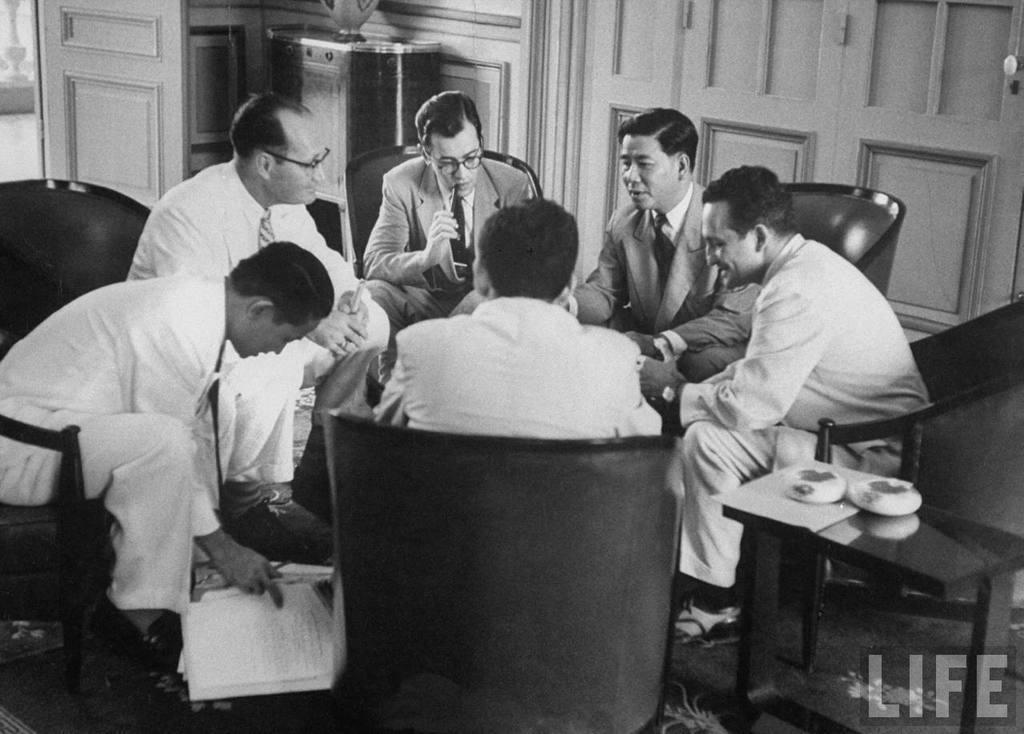Can you describe this image briefly? In this picture we can see man sitting on chair and talking to each other here person holding papers in his hand and in the background we can see cupboards, door, vase, pots. 